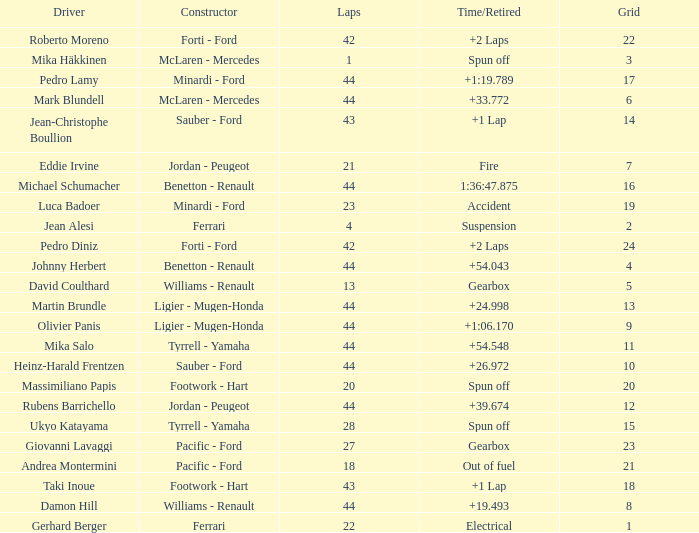Who built the car that ran out of fuel before 28 laps? Pacific - Ford. 